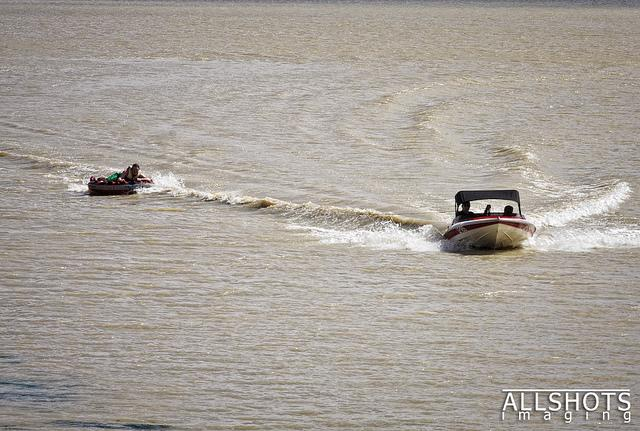How is the small vessel being moved? towed 